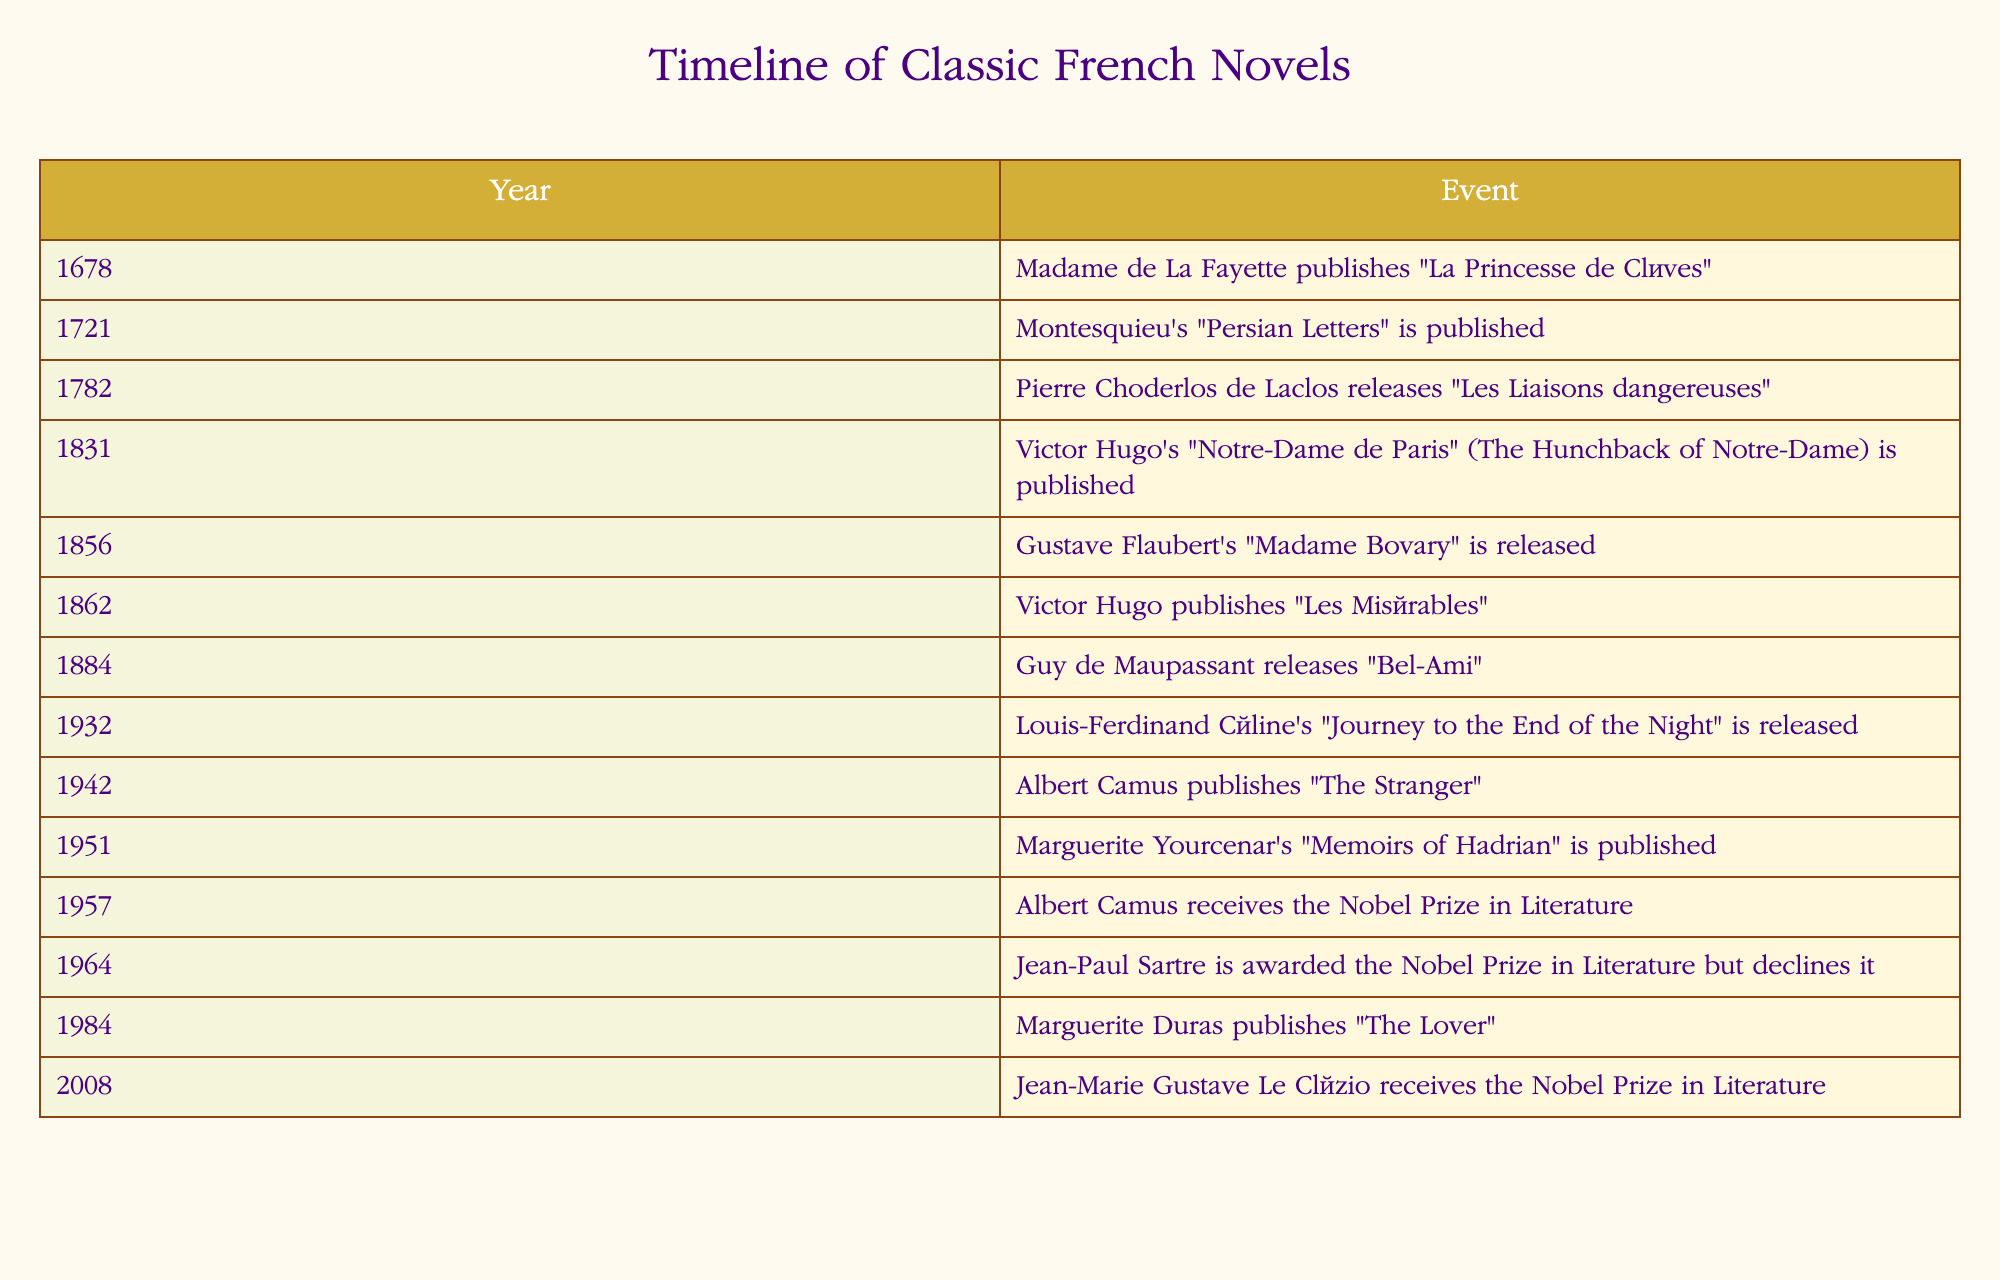What year was "Les Misérables" published? The table shows that "Les Misérables" was published in the year 1862.
Answer: 1862 Which two novels were published in the 19th century? The table indicates that Victor Hugo's "Notre-Dame de Paris" was published in 1831 and Gustave Flaubert's "Madame Bovary" in 1856, both of which fall within the 19th century.
Answer: Notre-Dame de Paris and Madame Bovary Did Marguerite Yourcenar publish "Memoirs of Hadrian" before Albert Camus published "The Stranger"? According to the table, "Memoirs of Hadrian" was published in 1951, while "The Stranger" was published in 1942. Since 1951 is after 1942, the answer is no.
Answer: No What is the time gap between the publication of "La Princesse de Clèves" and "Les Liaisons dangereuses"? The table shows "La Princesse de Clèves" was published in 1678 and "Les Liaisons dangereuses" in 1782. The time gap is 1782 - 1678 = 104 years.
Answer: 104 years Which author received the Nobel Prize in Literature first, Albert Camus or Jean-Paul Sartre? From the table, Albert Camus received the Nobel Prize in Literature in 1957, while Jean-Paul Sartre was awarded it in 1964 but declined it. Therefore, Camus was the first to receive the prize.
Answer: Albert Camus How many novels were published before the year 1800? Looking at the table, the novels published before 1800 are "La Princesse de Clèves" (1678), "Persian Letters" (1721), and "Les Liaisons dangereuses" (1782). This totals to three novels.
Answer: 3 Which author appears most frequently in the table? The table displays multiple works by Victor Hugo and Albert Camus. Victor Hugo authored "Notre-Dame de Paris" and "Les Misérables," while Albert Camus is listed for "The Stranger" and receiving his Nobel Prize. Since Victor Hugo has two works noted, he appears most frequently.
Answer: Victor Hugo Was "The Lover" published in the same decade as "Journey to the End of the Night"? "Journey to the End of the Night" was published in 1932, while "The Lover" was published in 1984. Since 1932 and 1984 are in different decades (1930s vs. 1980s), the answer is no.
Answer: No 